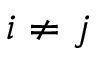Convert formula to latex. <formula><loc_0><loc_0><loc_500><loc_500>i \ne j</formula> 